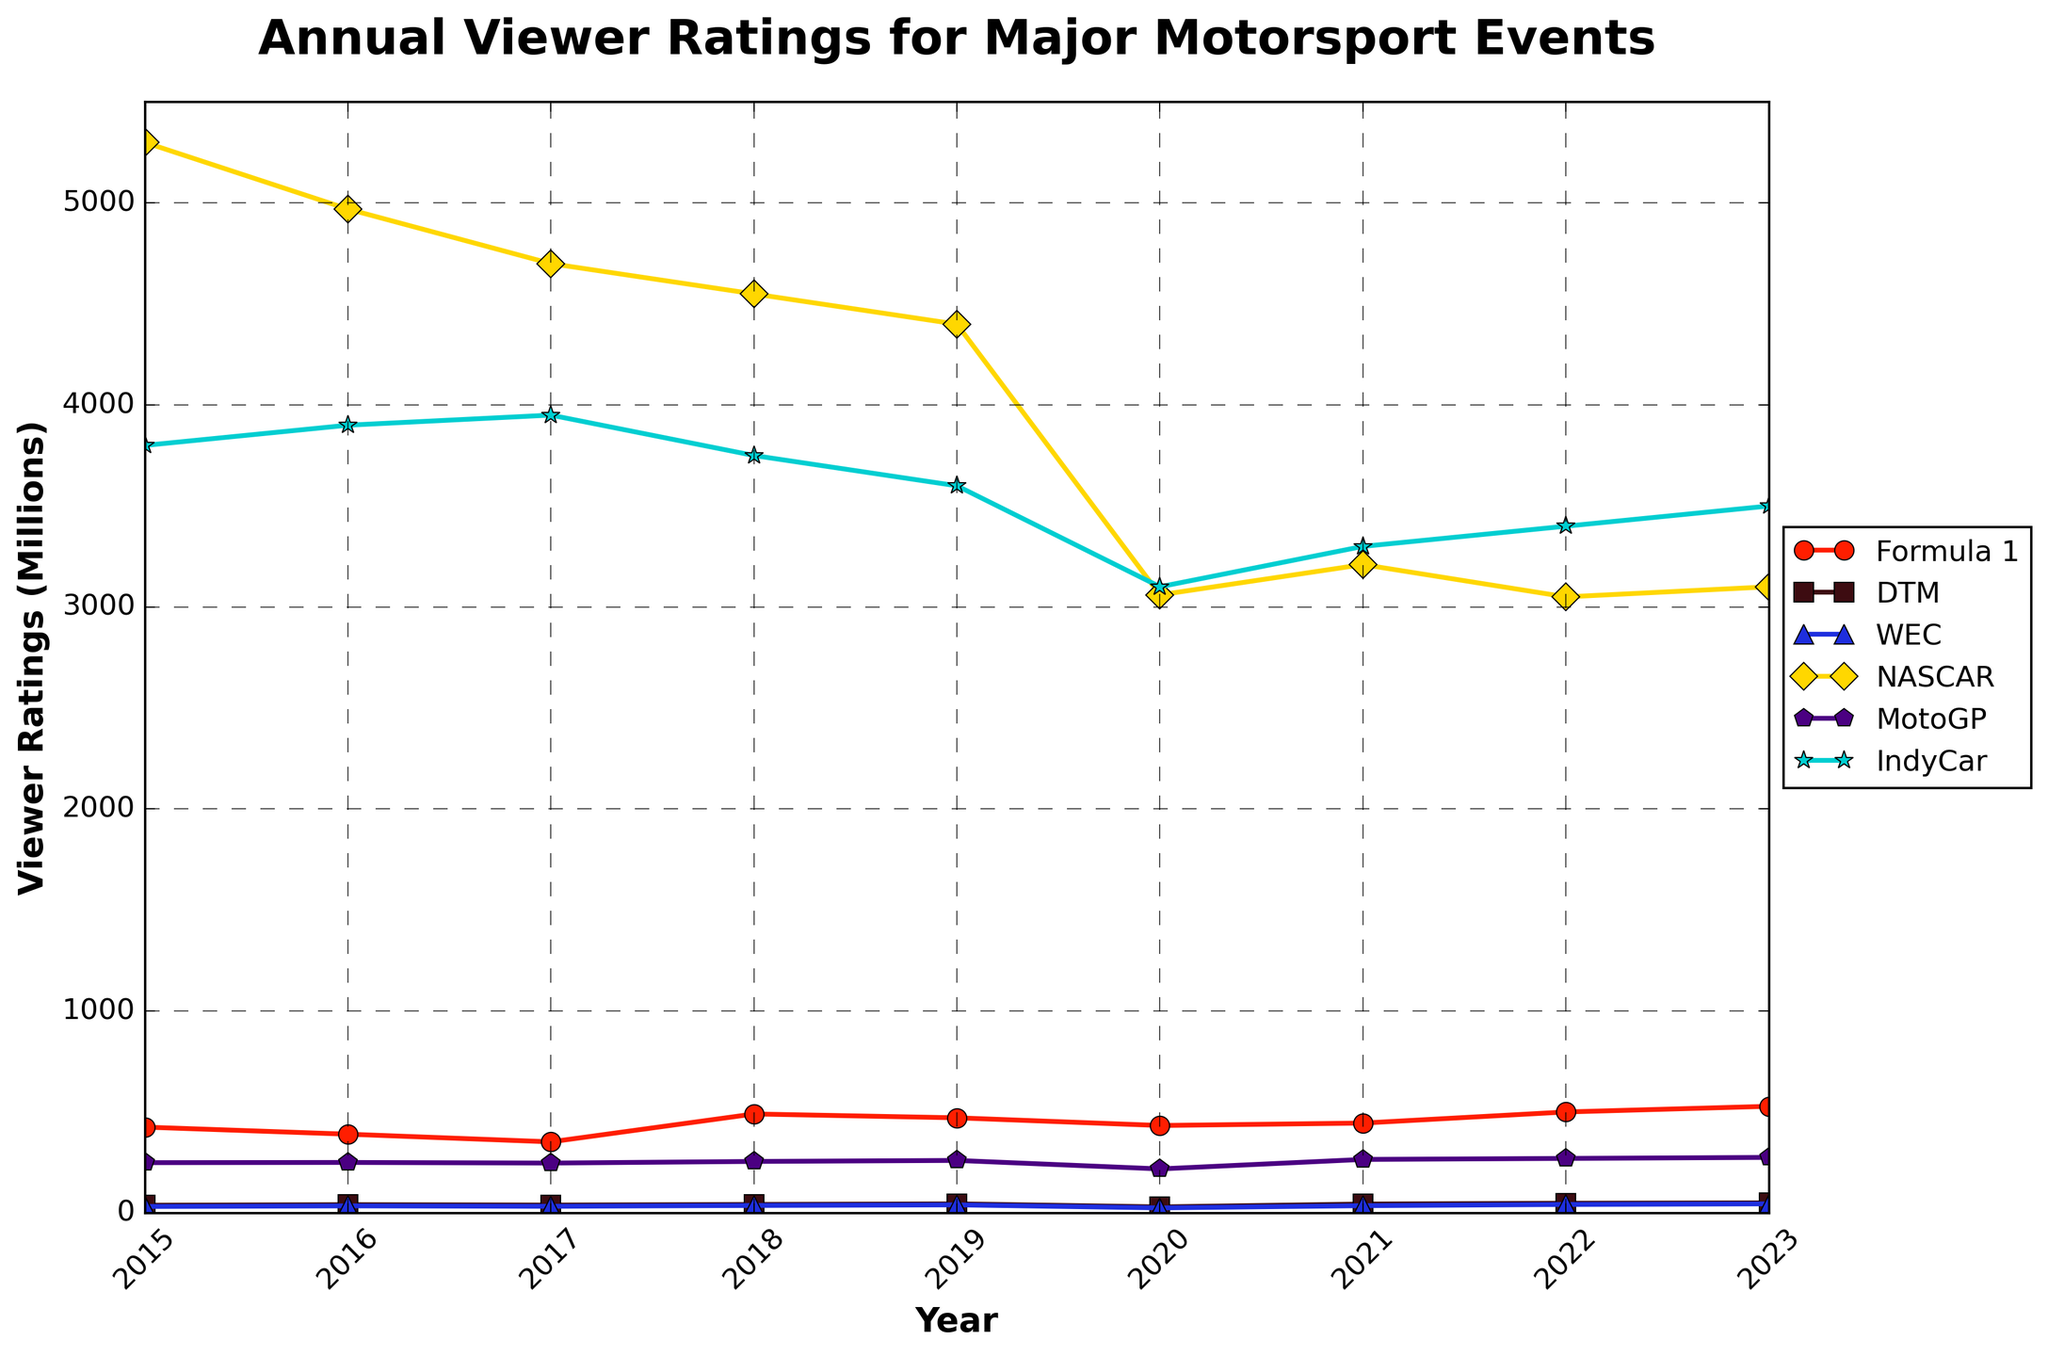What year did Formula 1 have the highest viewer ratings? By inspecting the line for Formula 1, find the year with the highest point on the plot. The highest point on the line is at 2023, which equals 528 million viewer ratings.
Answer: 2023 During which year did DTM have the lowest viewer ratings? By inspecting the line for DTM, see the point that is the lowest on the plot. The lowest point on the line is at 2020, which equals 30 million viewer ratings.
Answer: 2020 Which series had the steepest decline in viewer ratings between 2019 and 2020? Compare the slopes of the lines for each series between 2019 and 2020. The steepest decline will have the largest drop. NASCAR has the largest drop from 4400 to 3060.
Answer: NASCAR Compare MotoGP's viewer ratings in 2015 and 2020. Which year had higher ratings and by how much? Look at the MotoGP values for both years and calculate the difference. In 2015 it had 249 million viewer ratings and in 2020 it had 218 million. The difference is 249 - 218 = 31.
Answer: 2015, by 31 Which series had viewer ratings consistently increasing from 2020 to 2023? Look for lines with a consistent upward trend between 2020 and 2023. Both DTM and WEC show a consistent increase over these years.
Answer: DTM, WEC What is the average viewer ratings for IndyCar over the given years? Sum the ratings for IndyCar from 2015 to 2023 and divide by the number of years (9). (3800 + 3900 + 3950 + 3750 + 3600 + 3100 + 3300 + 3400 + 3500) / 9 = 3533.33
Answer: 3533.33 Which series had the highest viewer ratings in 2017? Compare the values for all series in 2017 and find the highest one. NASCAR had the highest with 4700 million viewer ratings.
Answer: NASCAR What is the difference in viewer ratings between Formula 1 and WEC in 2023? Subtract the viewer ratings of WEC from Formula 1 for the year 2023. Formula 1 had 528 million and WEC had 45 million, so 528 - 45 = 483.
Answer: 483 How did the viewer ratings for NASCAR change from 2015 to 2018? Look at the values for NASCAR in 2015 and 2018 and subtract the latter from the former. In 2015 it had 5300 million and in 2018 it had 4550 million, so 5300 - 4550 = 750.
Answer: Decreased by 750 